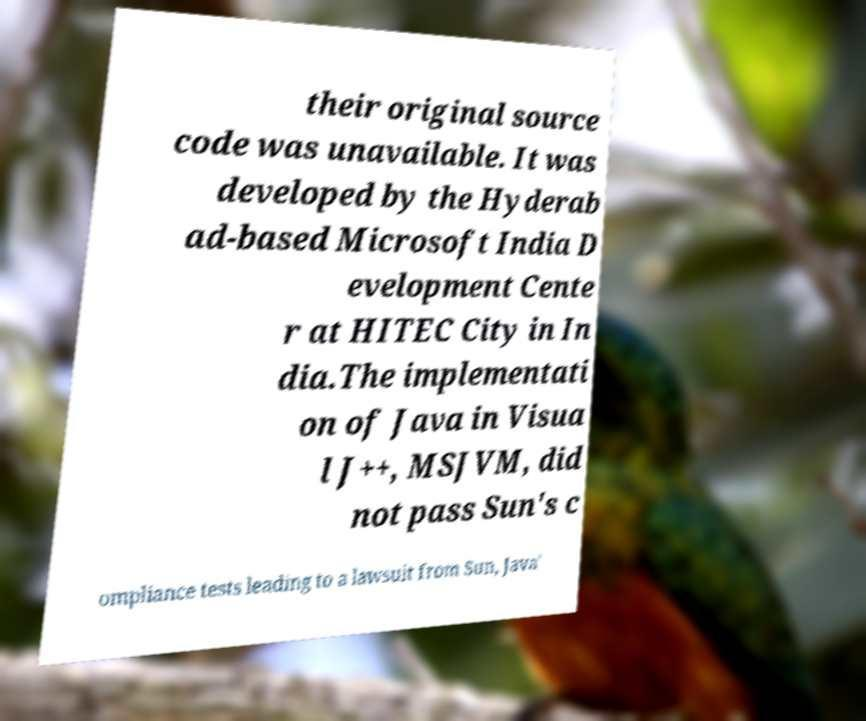There's text embedded in this image that I need extracted. Can you transcribe it verbatim? their original source code was unavailable. It was developed by the Hyderab ad-based Microsoft India D evelopment Cente r at HITEC City in In dia.The implementati on of Java in Visua l J++, MSJVM, did not pass Sun's c ompliance tests leading to a lawsuit from Sun, Java' 